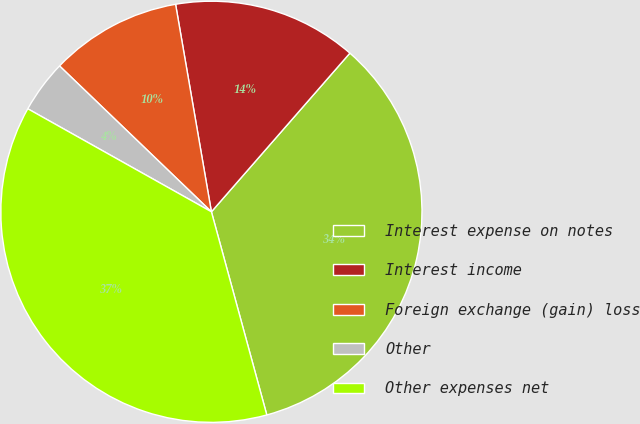Convert chart. <chart><loc_0><loc_0><loc_500><loc_500><pie_chart><fcel>Interest expense on notes<fcel>Interest income<fcel>Foreign exchange (gain) loss<fcel>Other<fcel>Other expenses net<nl><fcel>34.34%<fcel>14.14%<fcel>10.1%<fcel>4.04%<fcel>37.37%<nl></chart> 